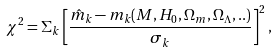Convert formula to latex. <formula><loc_0><loc_0><loc_500><loc_500>\chi ^ { 2 } = \Sigma _ { k } \left [ \frac { \hat { m } _ { k } - m _ { k } ( M , H _ { 0 } , \Omega _ { m } , \Omega _ { \Lambda } , . . ) } { \sigma _ { k } } \right ] ^ { 2 } ,</formula> 